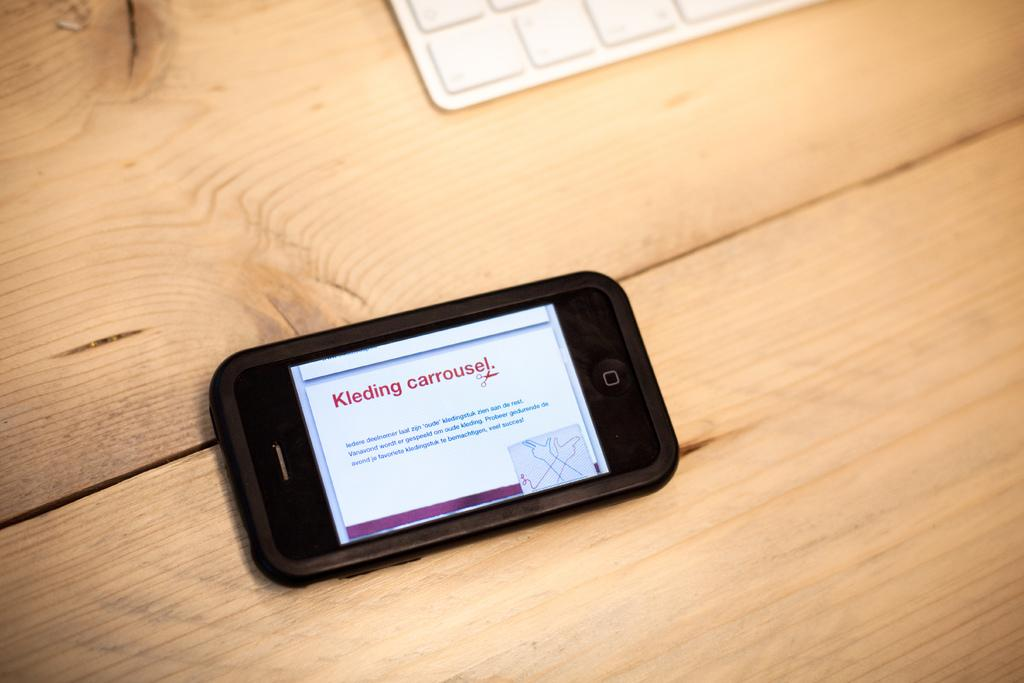Provide a one-sentence caption for the provided image. a cell phone with the words kleding carrouse on it in red. 